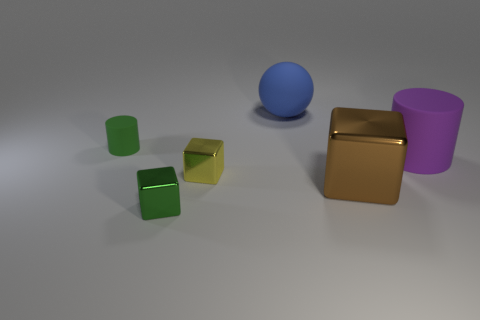Subtract all tiny cubes. How many cubes are left? 1 Add 3 large purple matte cylinders. How many objects exist? 9 Subtract all large blue matte objects. Subtract all cyan shiny spheres. How many objects are left? 5 Add 2 metallic things. How many metallic things are left? 5 Add 6 big blue rubber objects. How many big blue rubber objects exist? 7 Subtract all green cylinders. How many cylinders are left? 1 Subtract 1 green cylinders. How many objects are left? 5 Subtract all spheres. How many objects are left? 5 Subtract 1 cylinders. How many cylinders are left? 1 Subtract all yellow cylinders. Subtract all brown cubes. How many cylinders are left? 2 